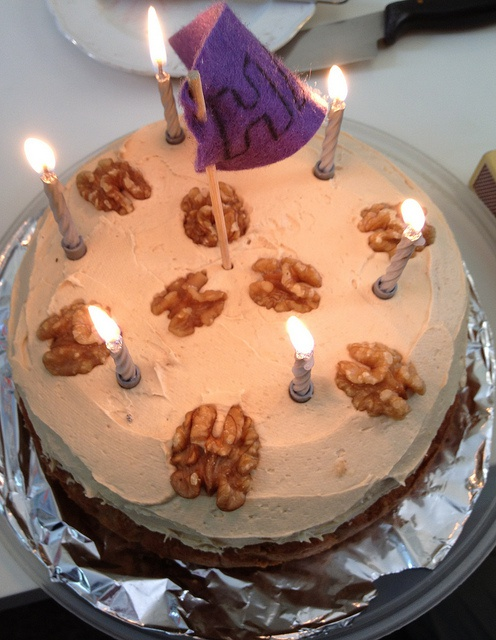Describe the objects in this image and their specific colors. I can see cake in darkgray, tan, and gray tones and knife in darkgray, black, and gray tones in this image. 